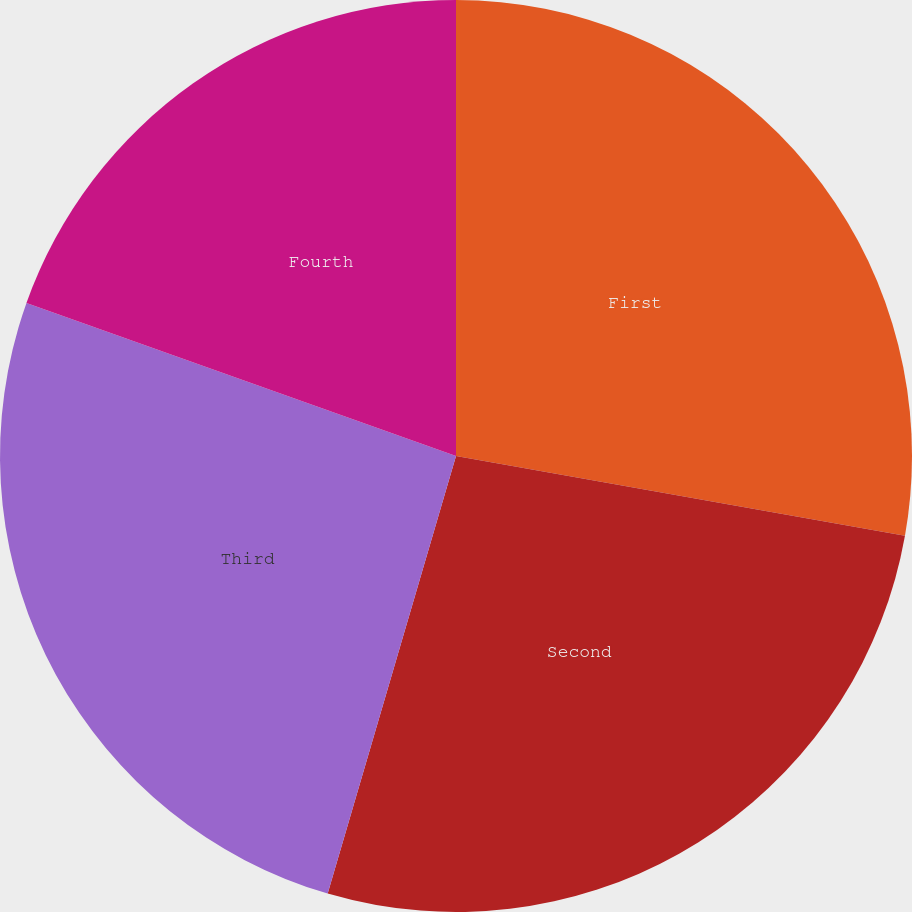Convert chart. <chart><loc_0><loc_0><loc_500><loc_500><pie_chart><fcel>First<fcel>Second<fcel>Third<fcel>Fourth<nl><fcel>27.8%<fcel>26.74%<fcel>25.91%<fcel>19.55%<nl></chart> 